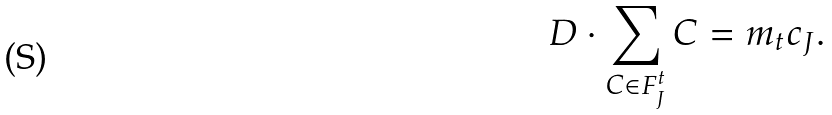Convert formula to latex. <formula><loc_0><loc_0><loc_500><loc_500>D \cdot \sum _ { C \in F ^ { t } _ { J } } C = m _ { t } c _ { J } .</formula> 